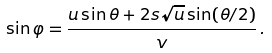<formula> <loc_0><loc_0><loc_500><loc_500>\sin \varphi = \frac { u \sin \theta + 2 s \sqrt { u } \sin ( \theta / 2 ) } { v } \, .</formula> 